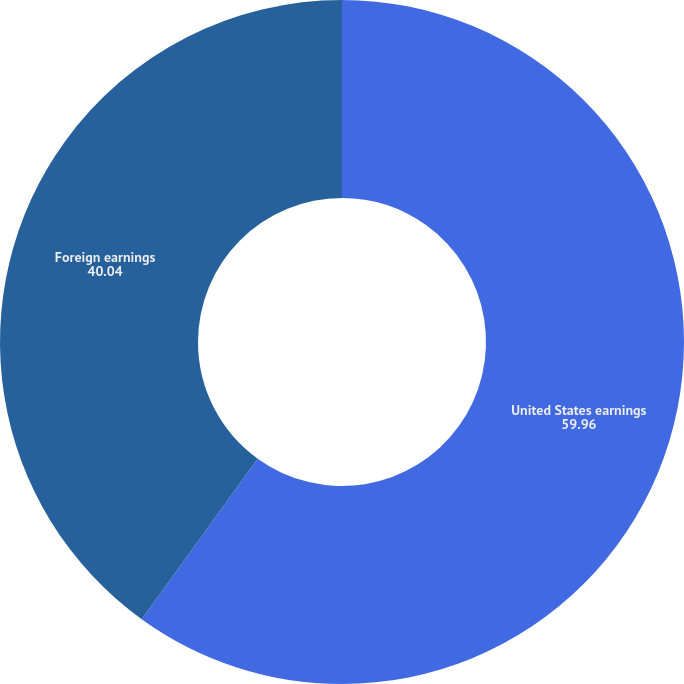Convert chart to OTSL. <chart><loc_0><loc_0><loc_500><loc_500><pie_chart><fcel>United States earnings<fcel>Foreign earnings<nl><fcel>59.96%<fcel>40.04%<nl></chart> 